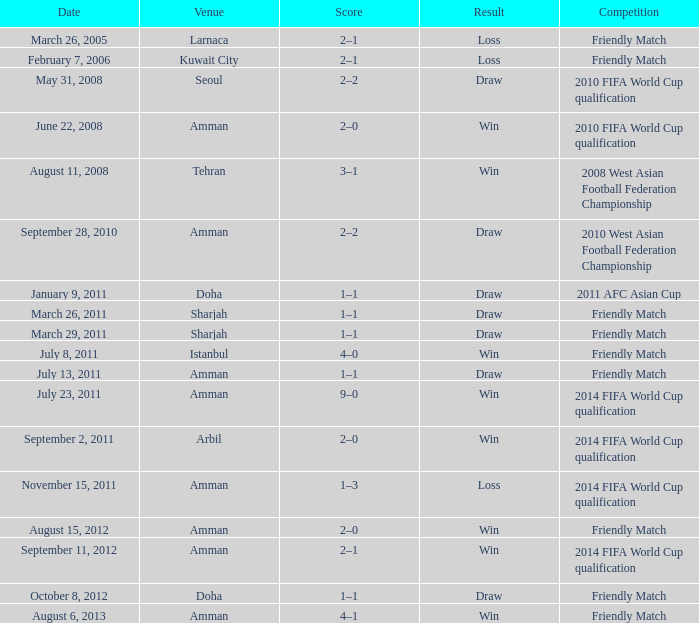What was the name of the competition that took place on may 31, 2008? 2010 FIFA World Cup qualification. 